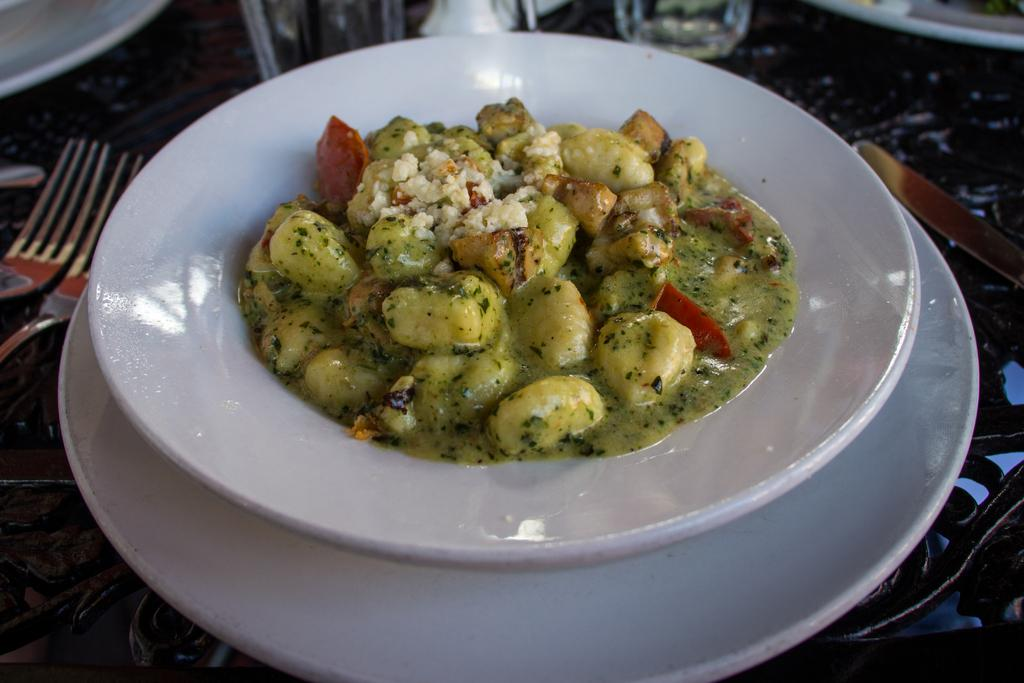What is on the plate that is visible in the image? There is a plate with food items in the image. What utensils can be seen in the foreground of the image? There are forks and a knife in the foreground of the image. What objects are located at the top side of the image? It appears that there are glasses and a plate at the top side of the image. What year is depicted in the image? There is no indication of a specific year in the image. What level of difficulty is represented by the objects in the image? The image does not depict a level of difficulty; it is a still life of various objects. 